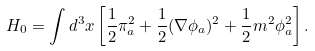<formula> <loc_0><loc_0><loc_500><loc_500>H _ { 0 } = \int d ^ { 3 } x \left [ \frac { 1 } { 2 } \pi _ { a } ^ { 2 } + \frac { 1 } { 2 } ( \nabla \phi _ { a } ) ^ { 2 } + \frac { 1 } { 2 } m ^ { 2 } \phi _ { a } ^ { 2 } \right ] .</formula> 